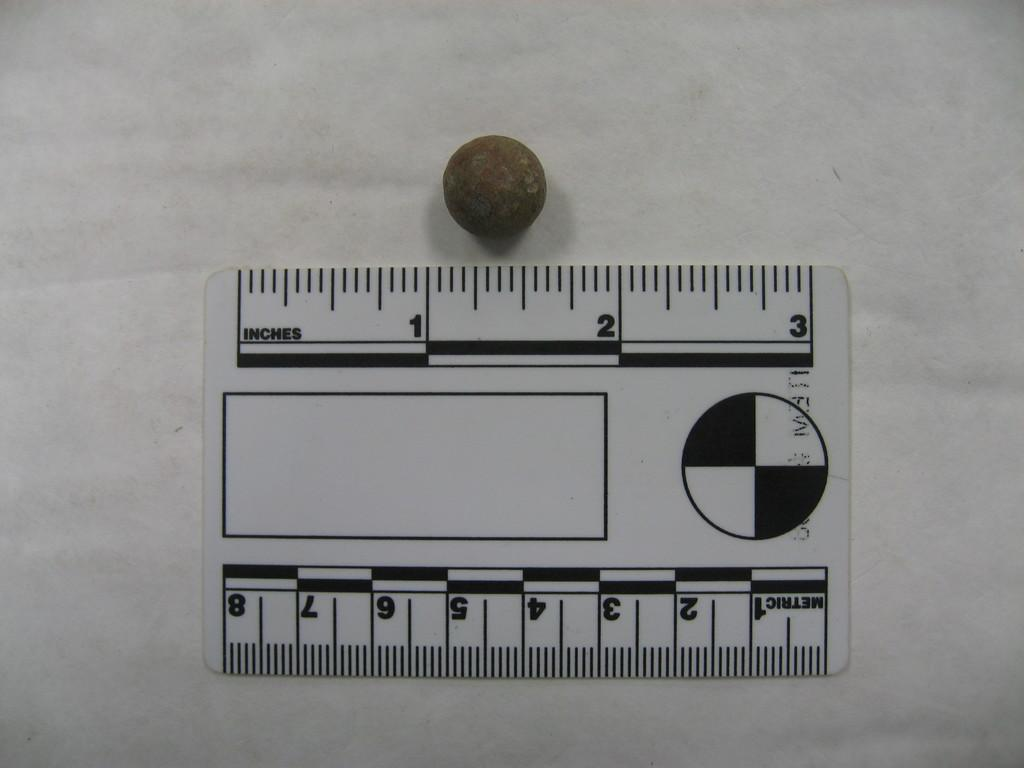<image>
Create a compact narrative representing the image presented. A ball of some sort being measured on the inches side of a ruler. 